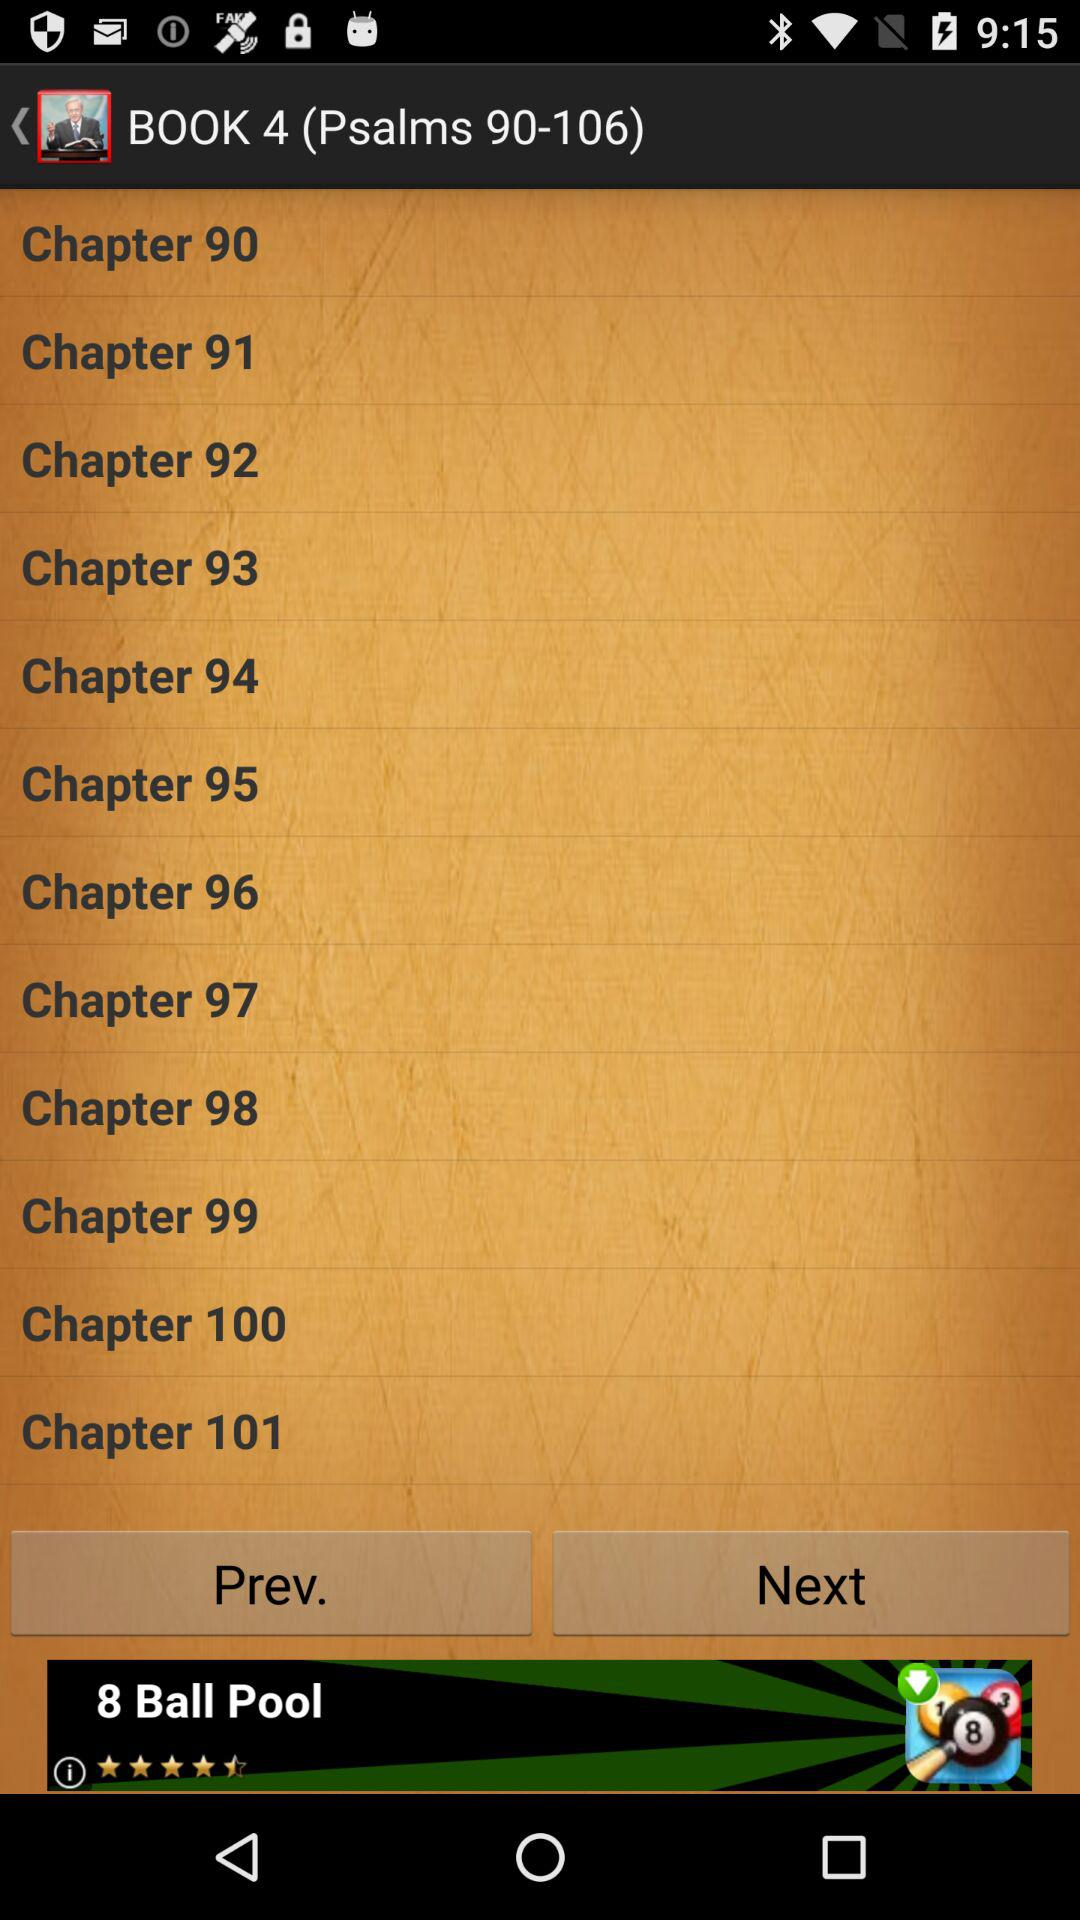Which book number contains Psalms 73–89? The number of the book that contains Psalms 73–89 is 3. 